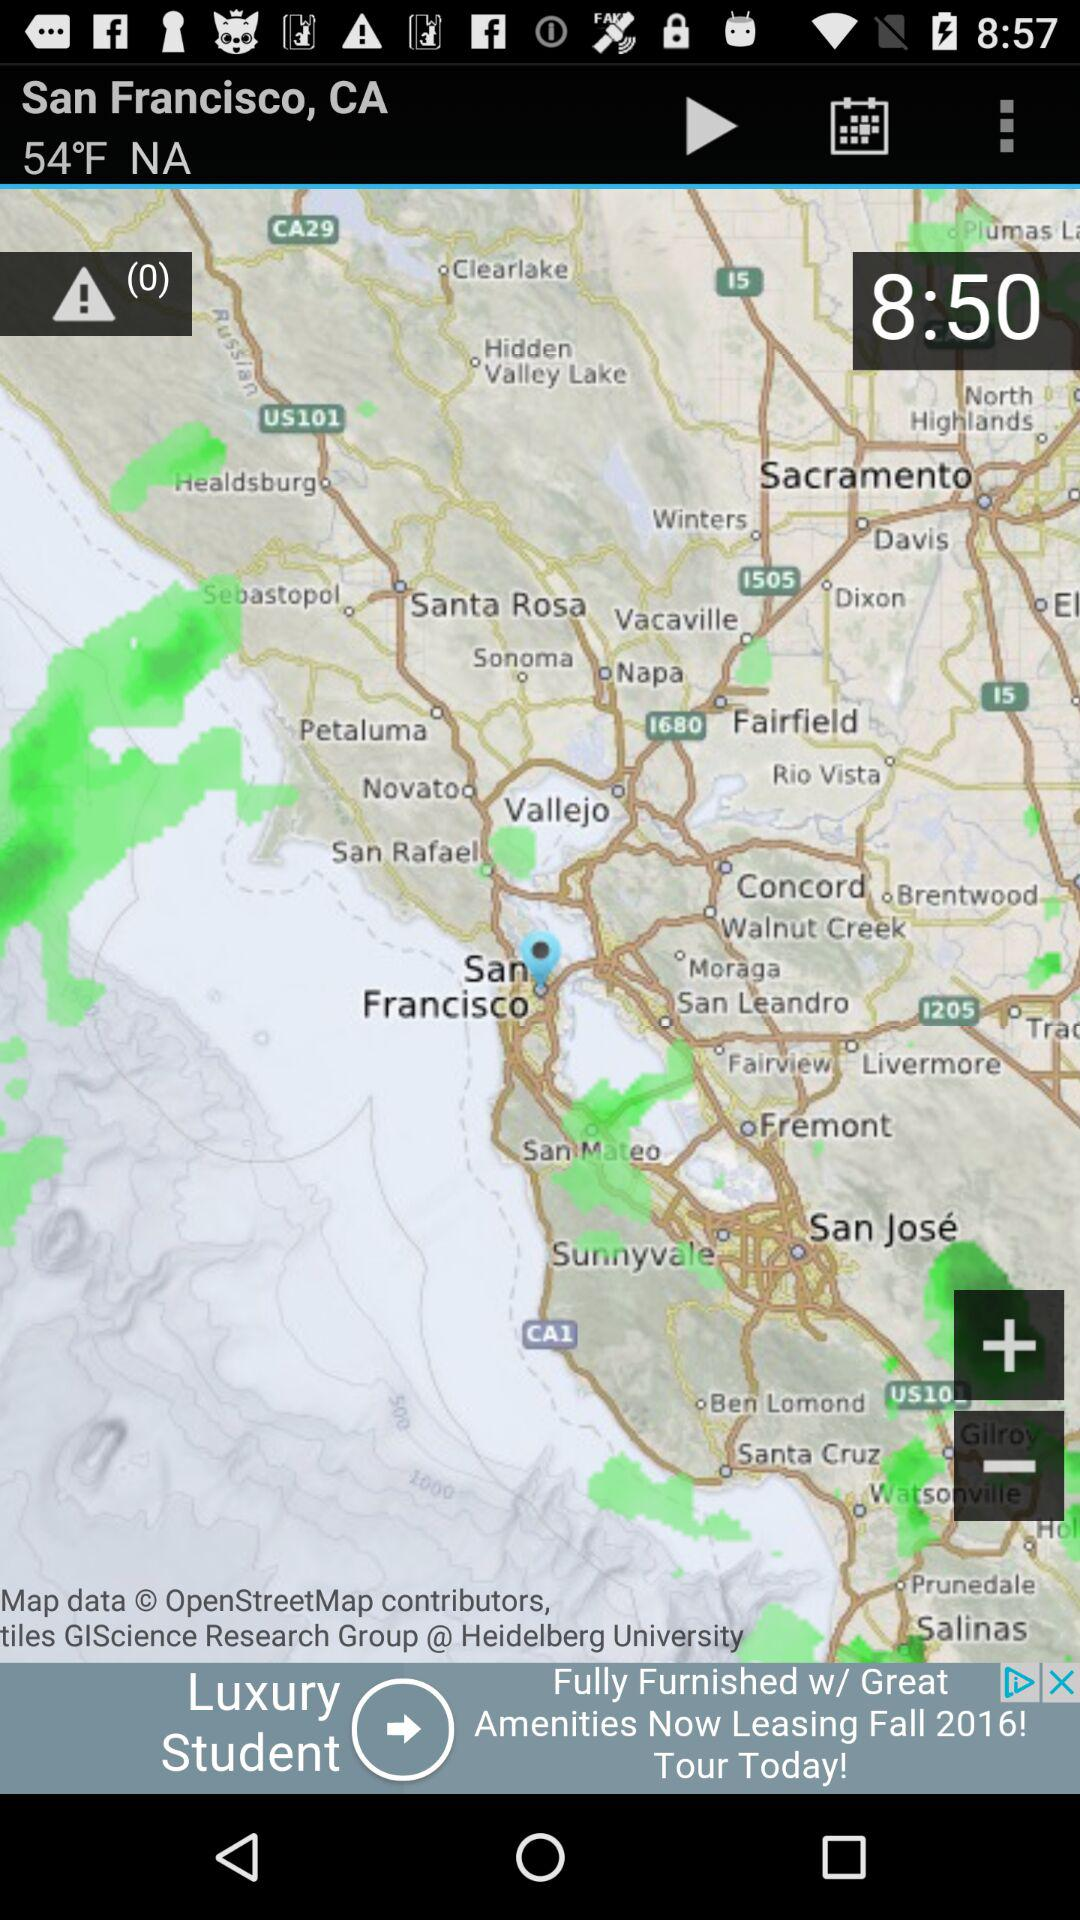How many degrees Fahrenheit is the current temperature?
Answer the question using a single word or phrase. 54°F 